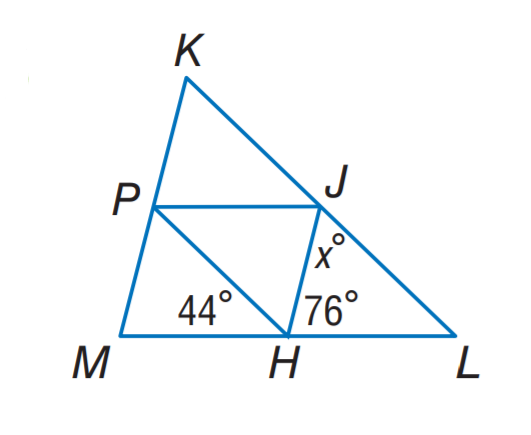Answer the mathemtical geometry problem and directly provide the correct option letter.
Question: J H, J P, and P H are midsegments of \triangle K L M. Find x.
Choices: A: 44 B: 56 C: 60 D: 76 C 